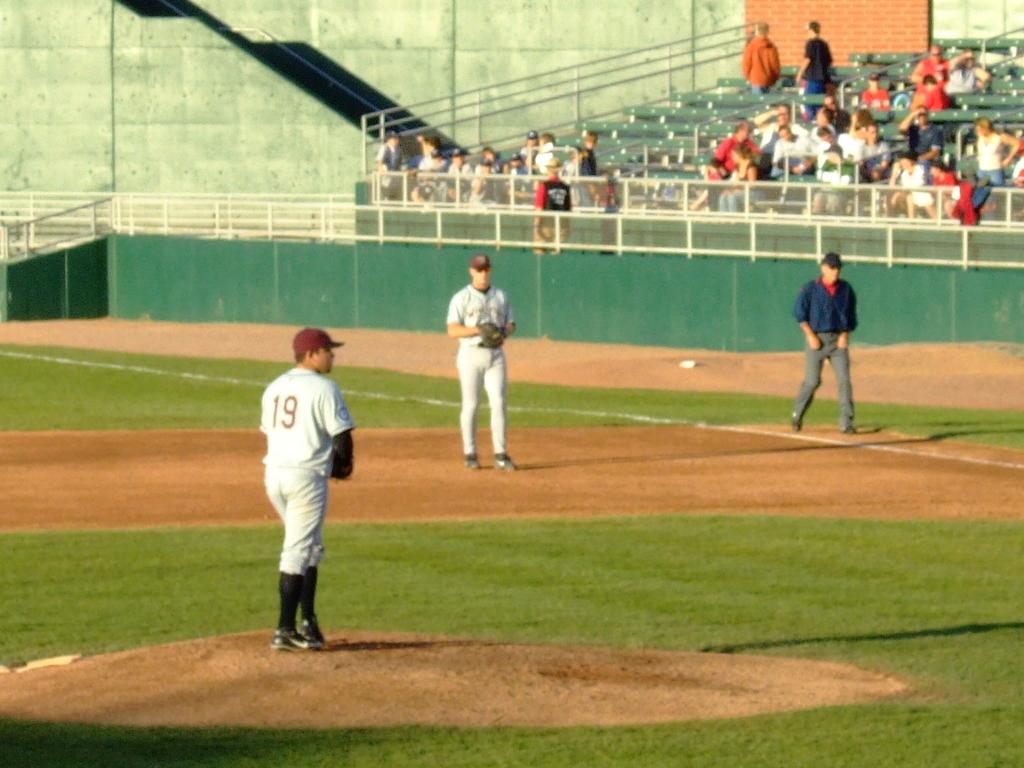What is the jersey number of the man on the left?
Your answer should be very brief. 19. 